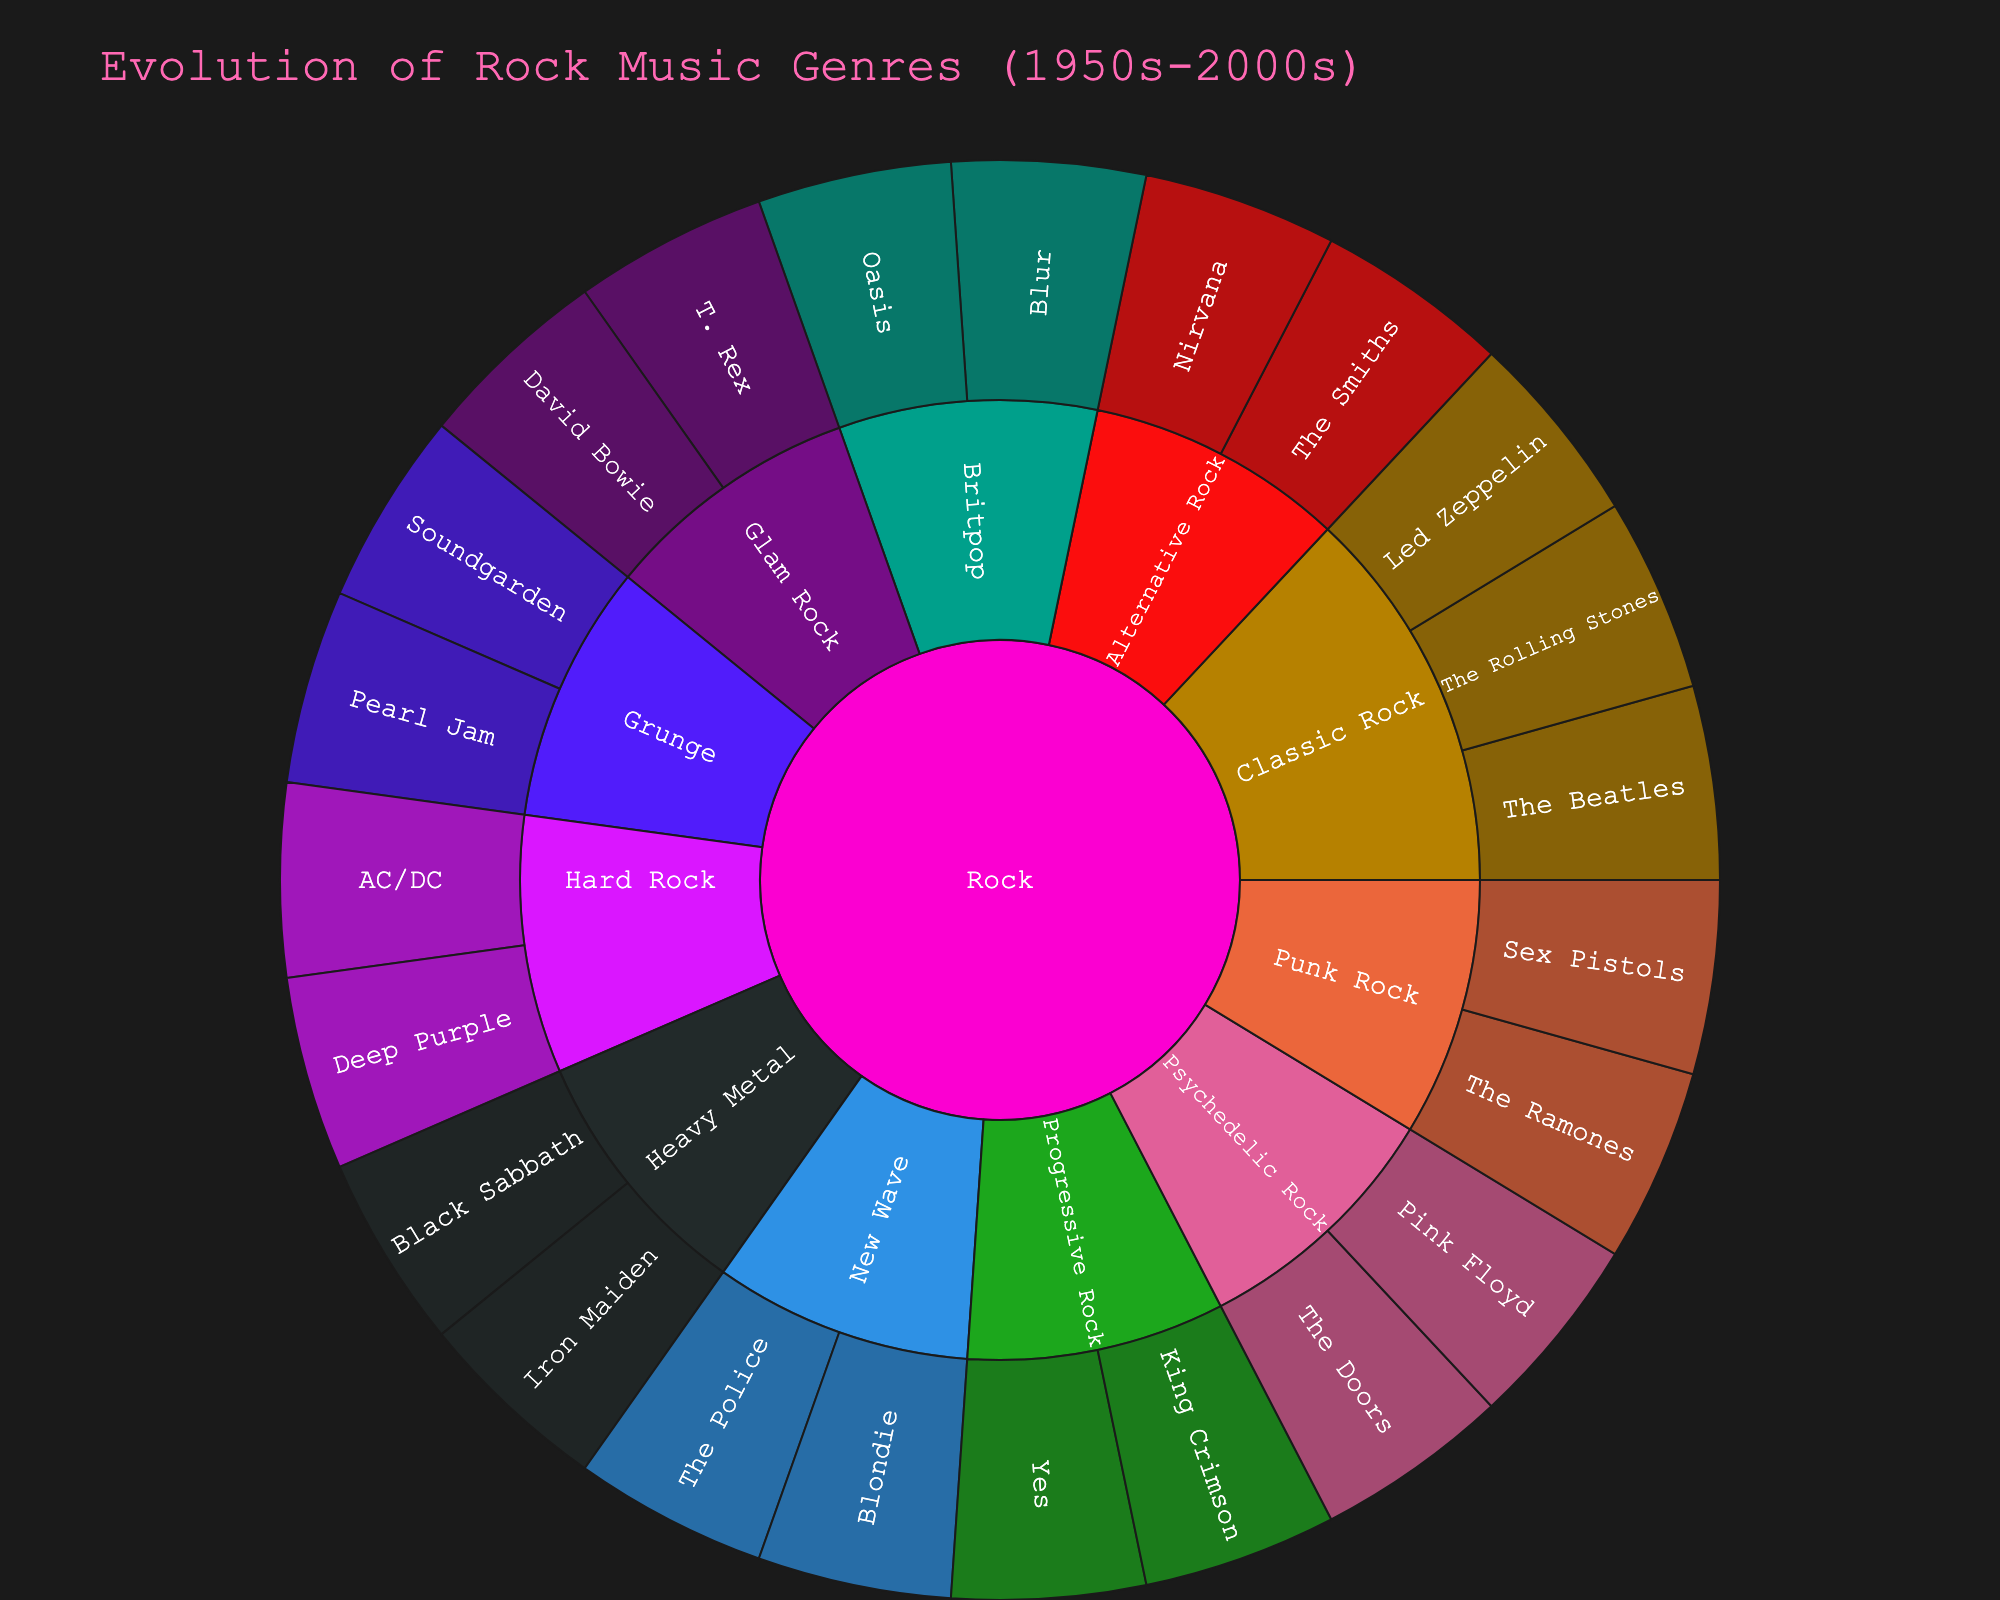what is the title of the figure? The title is displayed prominently at the top of the figure in larger text.
Answer: Evolution of Rock Music Genres (1950s-2000s) Which subgenres are corresponding to "Nirvana" in the Sunburst Plot? According to the visual representation, you can follow the path from the band name "Nirvana" to its subgenre.
Answer: Alternative Rock How many subgenres are shown in the "Rock" genre? Start from the "Rock" label and count each outer segment representing distinct subgenres.
Answer: Eight Which subgenre has the most bands represented? Identify the subgenre with the largest number of bands visible in its segment. _ Note: Verify by counting the number of band's bands under each subgenre.
Answer: Classic Rock Which two bands are associated with "Punk Rock"? Look at the "Punk Rock" subgenre segment and identify the bands connected to it.
Answer: The Ramones and Sex Pistols Which band is linked to both "Progressive Rock" and "King Crimson"? Starting from "Progressive Rock," identify the bands listed, then confirm the link with "King Crimson."
Answer: Yes Compare the number of bands in "Grunge" and "Glam Rock". Which has more bands? Count the bands for Grunge (Pearl Jam, Soundgarden) and compare with Glam Rock (David Bowie, T. Rex) to determine which is greater.
Answer: Both have two bands How many bands are under "New Wave"? Locate the "New Wave" subgenre and count the bands listed under it.
Answer: Two bands Which subgenre does the band "AC/DC" belong to? Identify the path leading from "AC/DC" to its subgenre.
Answer: Hard Rock What are the colors used to represent the subgenres in the Rock genre? Examine the color segments in the Rock genre to list out colors used for distinct subgenres.
Answer: Colors vary by subgenre, mostly bold distinct colors (Exact color names are subjective to interpretation) 